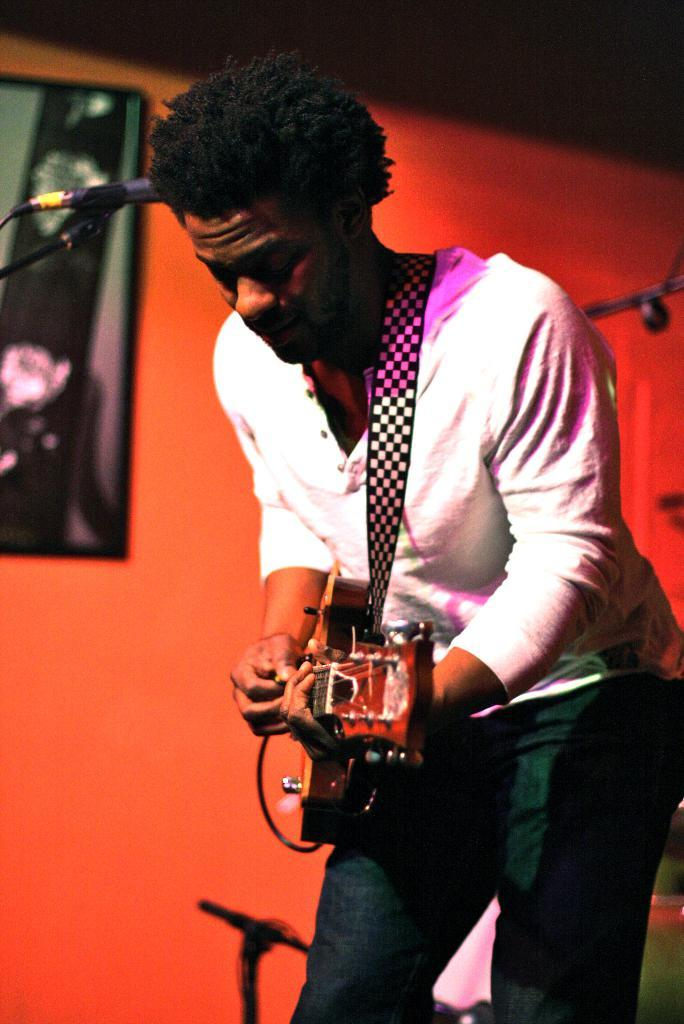What is the man in the image doing? The man is playing a guitar in the image. What can be seen behind the man? There is a wall behind the man. Are there any objects on the wall? Yes, there is a photo frame on the wall. What other item is visible in the image? A microphone is present in the top left side of the image. What type of hair is the man wearing in the image? The man is not wearing any hair in the image; he is bald. How many eggs are visible in the image? There are no eggs present in the image. 